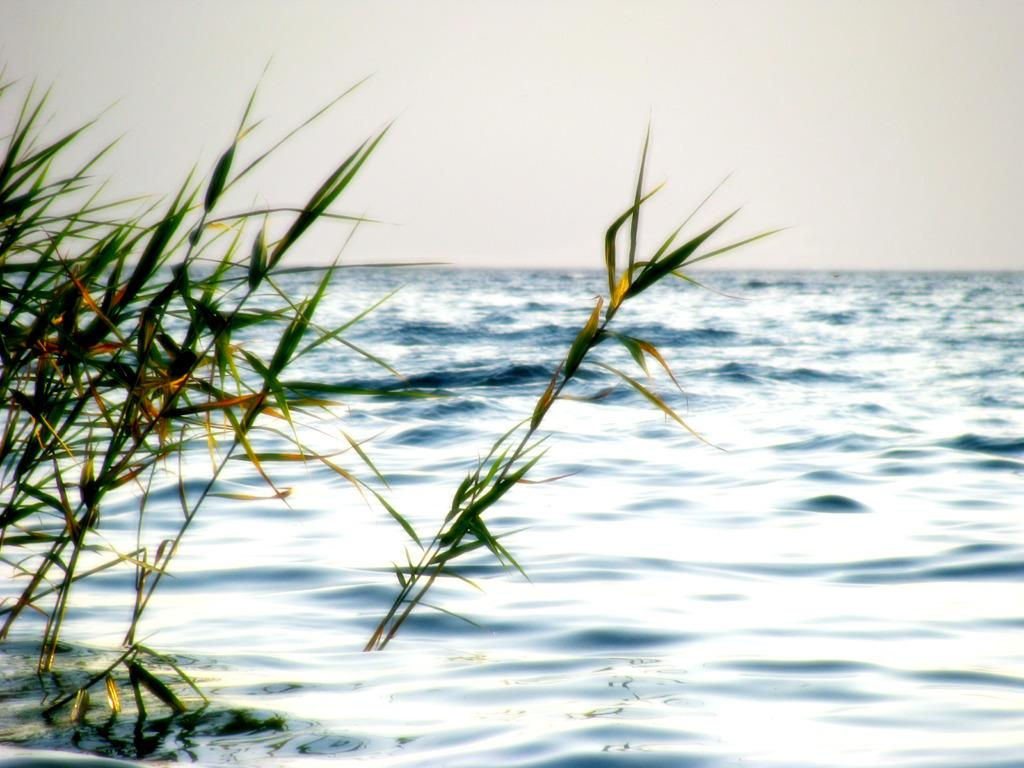What type of vegetation is in the water in the image? There is grass in the water in the image. What part of the natural environment is visible in the image? The sky is visible in the image. What type of pear is being used as a language in the image? There is no pear or language present in the image. 